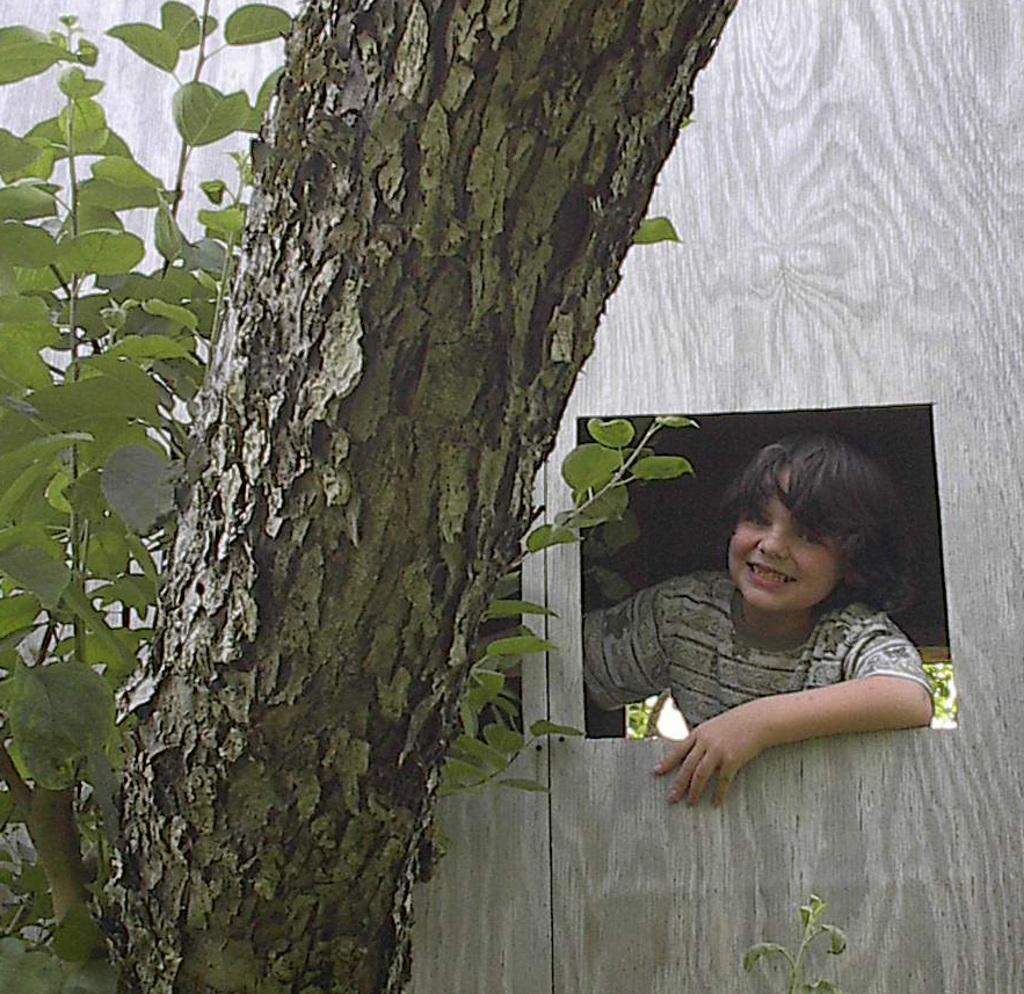Who is present in the image? There is a boy in the image. What natural element can be seen in the image? There is a tree in the image. What type of vegetation is visible in the image? There are plants in the image. What man-made structure is present in the image? There is a wall in the image. What type of lake can be seen in the image? There is no lake present in the image. 